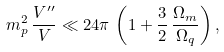Convert formula to latex. <formula><loc_0><loc_0><loc_500><loc_500>m _ { p } ^ { 2 } \, \frac { V ^ { \prime \prime } } { V } \ll 2 4 \pi \, \left ( 1 + \frac { 3 } { 2 } \, \frac { \Omega _ { m } } { \Omega _ { q } } \right ) ,</formula> 